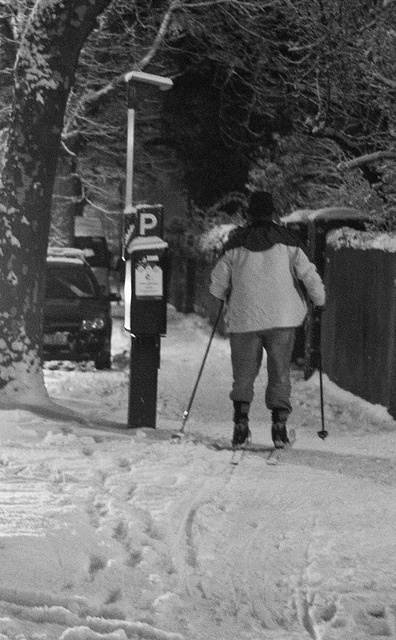Describe the objects in this image and their specific colors. I can see people in black, gray, silver, and darkgray tones, car in silver, black, gray, darkgray, and lightgray tones, parking meter in silver, black, darkgray, gray, and white tones, car in silver, black, and gray tones, and car in silver, darkgray, gray, lightgray, and black tones in this image. 